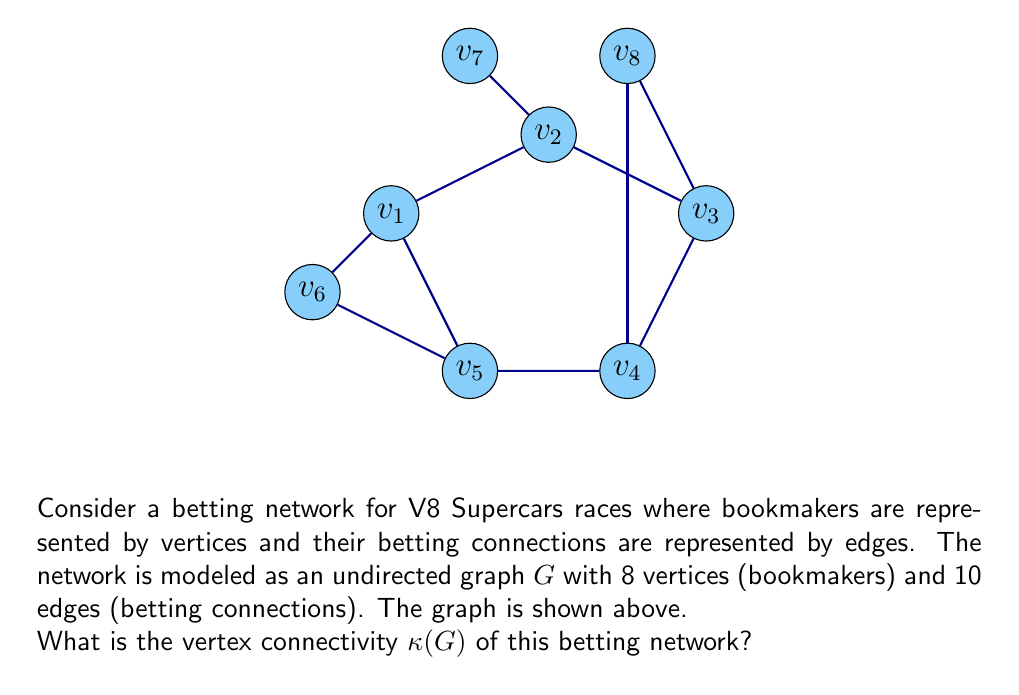Teach me how to tackle this problem. To find the vertex connectivity $\kappa(G)$ of the graph, we need to determine the minimum number of vertices that need to be removed to disconnect the graph. Let's approach this step-by-step:

1) First, observe that the graph is connected, so $\kappa(G) \geq 1$.

2) We can see that removing any single vertex does not disconnect the graph, so $\kappa(G) \geq 2$.

3) Now, let's try removing two vertices:
   - If we remove $v_1$ and $v_2$, the graph remains connected.
   - If we remove $v_1$ and $v_5$, the graph remains connected.
   - However, if we remove $v_1$ and $v_3$, the graph becomes disconnected.

4) The removal of vertices $v_1$ and $v_3$ separates the graph into three components:
   - Component 1: $\{v_2, v_6, v_7\}$
   - Component 2: $\{v_4, v_5\}$
   - Component 3: $\{v_8\}$

5) Since we found a set of two vertices whose removal disconnects the graph, and we previously established that removing any single vertex does not disconnect the graph, we can conclude that $\kappa(G) = 2$.

6) In the context of the betting network, this means that at least two bookmakers need to cease operations or cut their connections for the betting network to become fragmented.
Answer: $\kappa(G) = 2$ 